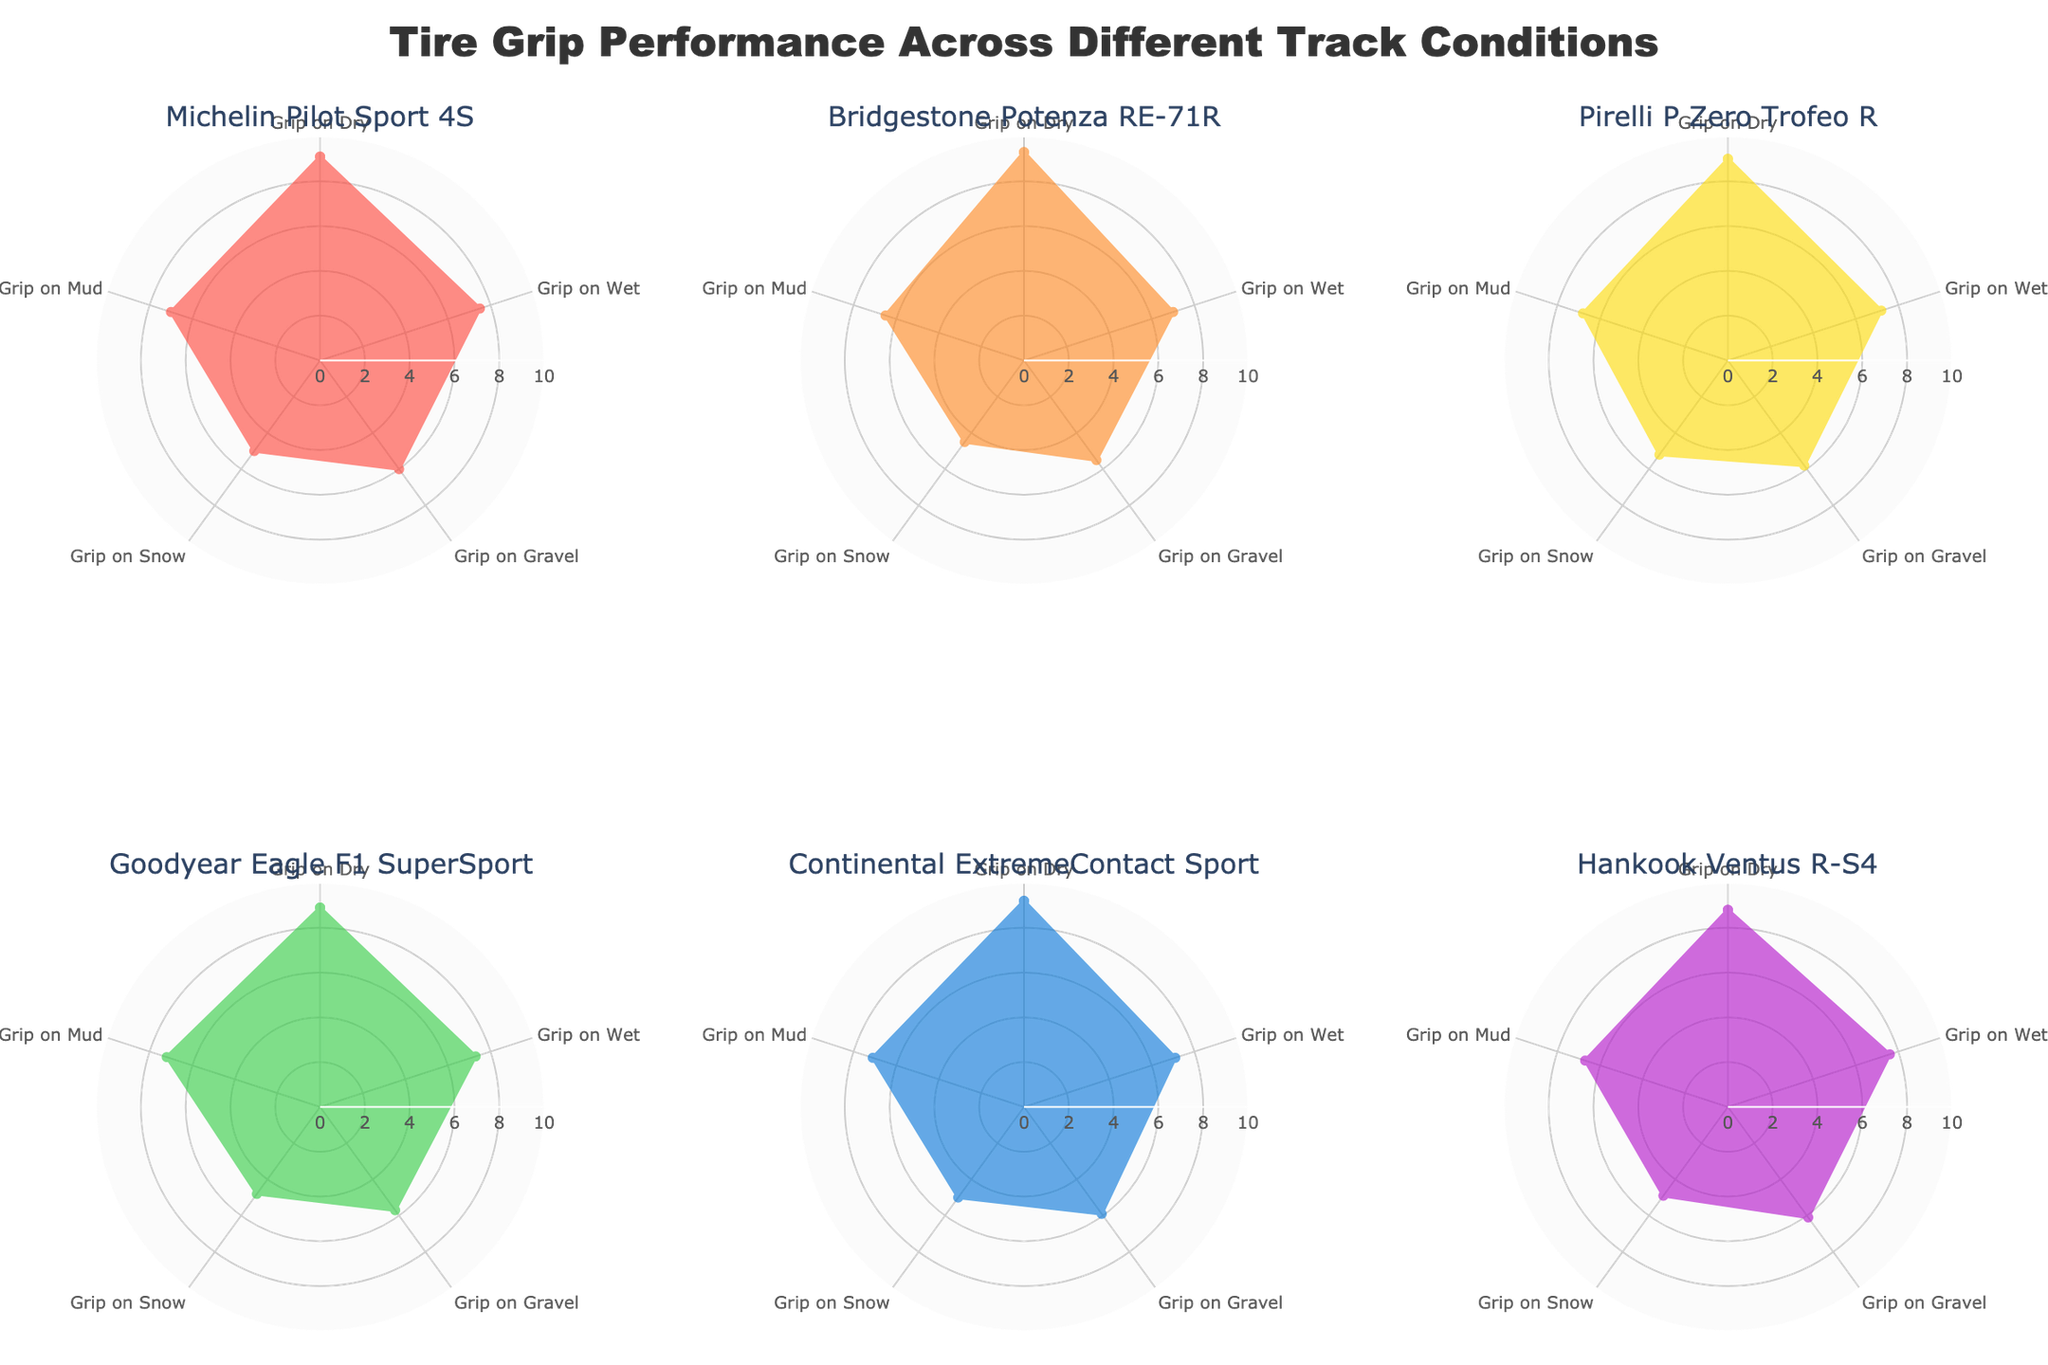What is the primary title of the figure? The title is displayed at the top center of the figure, and it reads "Tire Grip Performance Across Different Track Conditions."
Answer: Tire Grip Performance Across Different Track Conditions Which tire has the highest grip on dry surfaces? Each tire's radar chart shows the "Grip on Dry" value. Among the tires, Bridgestone Potenza RE-71R has the highest value at 9.3.
Answer: Bridgestone Potenza RE-71R How does Goodyear Eagle F1 SuperSport perform on wet conditions compared to snow conditions? By examining Goodyear Eagle F1 SuperSport's radar chart, the grip value on wet is 7.3, and on snow it is 4.8. The tire performs better on wet conditions as 7.3 > 4.8.
Answer: Better on wet Which tire has the most balanced performance across all track conditions? A balanced performance means similar values for all conditions. Hankook Ventus R-S4 shows 8.8 on dry, 7.6 on wet, 6.1 on gravel, 4.9 on snow, and 6.7 on mud, indicating more consistency across conditions compared to others.
Answer: Hankook Ventus R-S4 What is the range of grip values for Michelin Pilot Sport 4S on different track conditions? Michelin Pilot Sport 4S has grip values from 5.0 to 9.1. The range is calculated by subtracting the minimum value from the maximum value: 9.1 - 5.0 = 4.1.
Answer: 4.1 Between Pirelli P Zero Trofeo R and Continental ExtremeContact Sport, which tire has a better average performance on Gravel and Mud? Pirelli has values of 5.8 (Gravel) and 6.8 (Mud) with an average of (5.8 + 6.8)/2 = 6.3. Continental has values of 5.9 (Gravel) and 7.1 (Mud) with an average of (5.9 + 7.1)/2 = 6.5. Continental has a slightly better average.
Answer: Continental ExtremeContact Sport Compare the performance of all tires on snow. Which tire performs best? Looking at the snow grip values for all tires: Michelin Pilot Sport 4S (5.0), Bridgestone Potenza RE-71R (4.5), Pirelli P Zero Trofeo R (5.2), Goodyear Eagle F1 SuperSport (4.8), Continental ExtremeContact Sport (5.0), Hankook Ventus R-S4 (4.9). Pirelli P Zero Trofeo R performs the best on snow with a value of 5.2.
Answer: Pirelli P Zero Trofeo R What is the combined grip performance of Michelin Pilot Sport 4S on dry and wet surfaces? Adding the grip values of Michelin Pilot Sport 4S on dry (9.1) and wet (7.5) surfaces: 9.1 + 7.5 = 16.6.
Answer: 16.6 Which tire shows the lowest grip on gravel, and what is the value? Observing the grip values on gravel for all tires, the lowest is 5.5 for Bridgestone Potenza RE-71R.
Answer: Bridgestone Potenza RE-71R, 5.5 